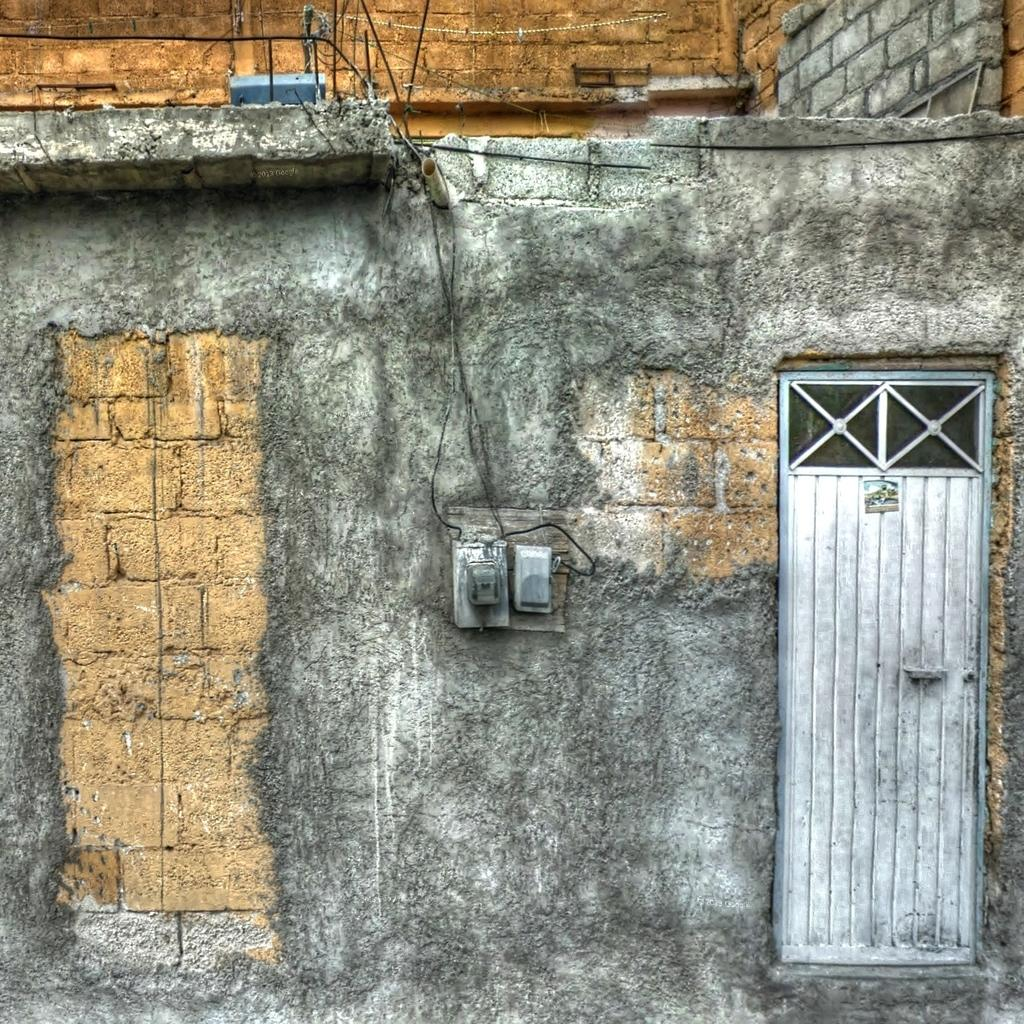What is the main object in the center of the image? There is a power switch board in the center of the image. What is located on the right side of the image? There is a door on the right side of the image. Where is the door situated? The door is on a wall. What can be seen in the background of the image? There is a building in the background of the image. What type of brush is being used to paint the door in the image? There is no brush or painting activity present in the image. 